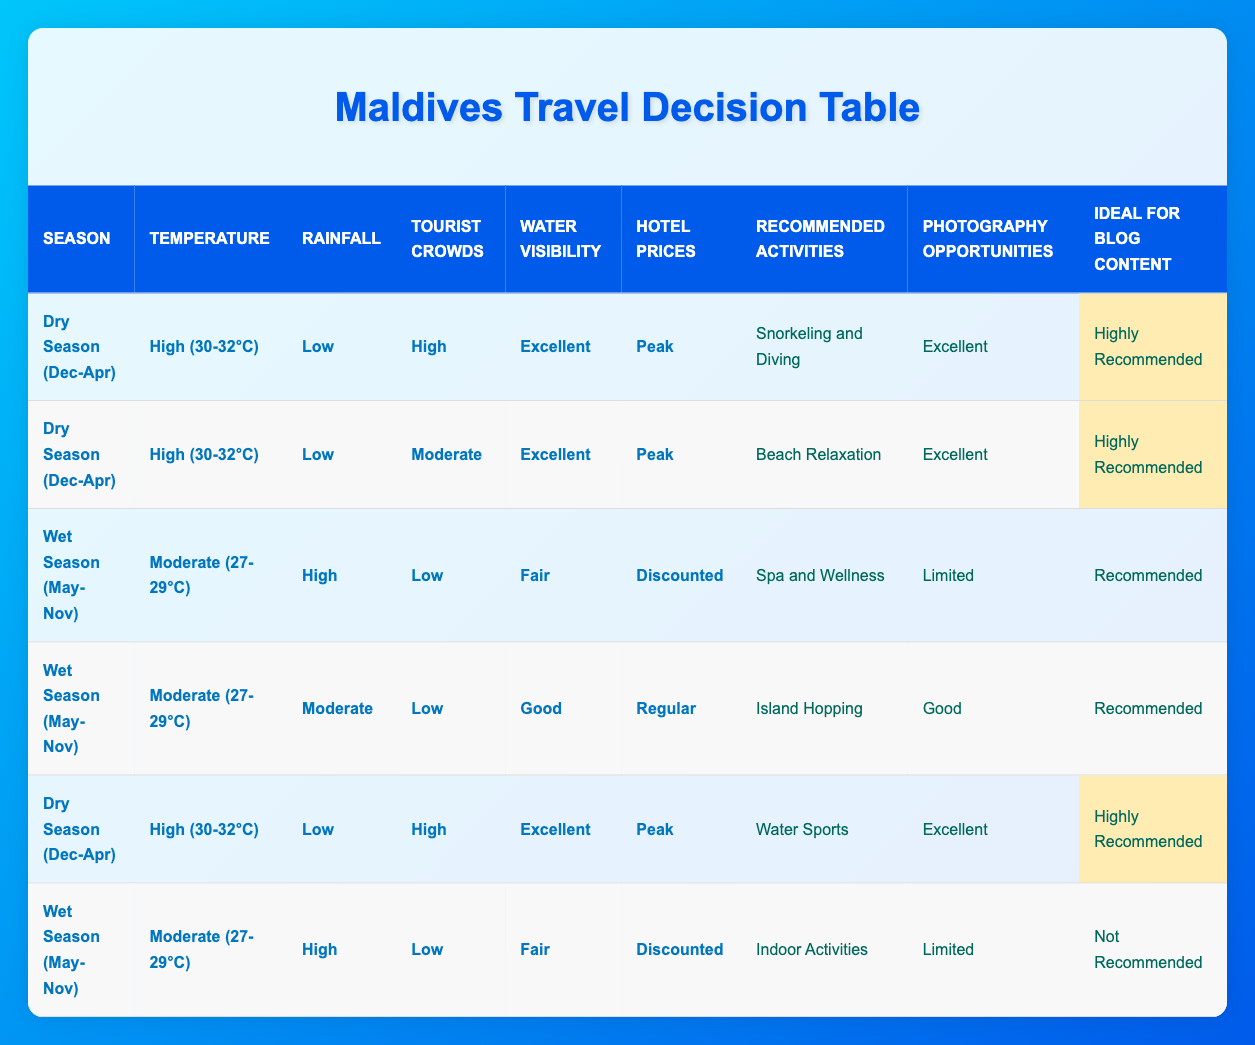What are the recommended activities during the Dry Season with High temperature and Low rainfall? According to the table, during the Dry Season with High temperature and Low rainfall, the recommended activities listed are Snorkeling and Diving, Beach Relaxation, and Water Sports.
Answer: Snorkeling and Diving, Beach Relaxation, Water Sports During which season is Spa and Wellness recommended? The table shows that Spa and Wellness is recommended during the Wet Season when the temperature is Moderate, rainfall is High, tourist crowds are Low, and hotel prices are Discounted.
Answer: Wet Season What is the photography opportunity during the Dry Season with High crowds? The table indicates that during the Dry Season with High crowds, the photography opportunities are Excellent, as shown in multiple entries for activities like Snorkeling and Diving and Water Sports.
Answer: Excellent Is Indoor Activities recommended during the Wet Season with Moderate temperature? The table indicates that Indoor Activities are classified as Not Recommended during the Wet Season with Moderate temperature, High rainfall, Low tourist crowds, and Discounted hotel prices.
Answer: No What is the ideal season for beach relaxation and what are the conditions? The table shows that Beach Relaxation is recommended during the Dry Season when the temperature is High (30-32°C) with Low rainfall and Moderate tourist crowds, under Peak hotel prices.
Answer: Dry Season with High temperature and Low rainfall What are the differences in photography opportunities between the Dry Season and Wet Season? The table reveals that during the Dry Season, photography opportunities range from Excellent to Good, while in the Wet Season, it ranges from Limited to Good, making the Dry Season more favorable for photography.
Answer: Dry Season is generally better for photography 